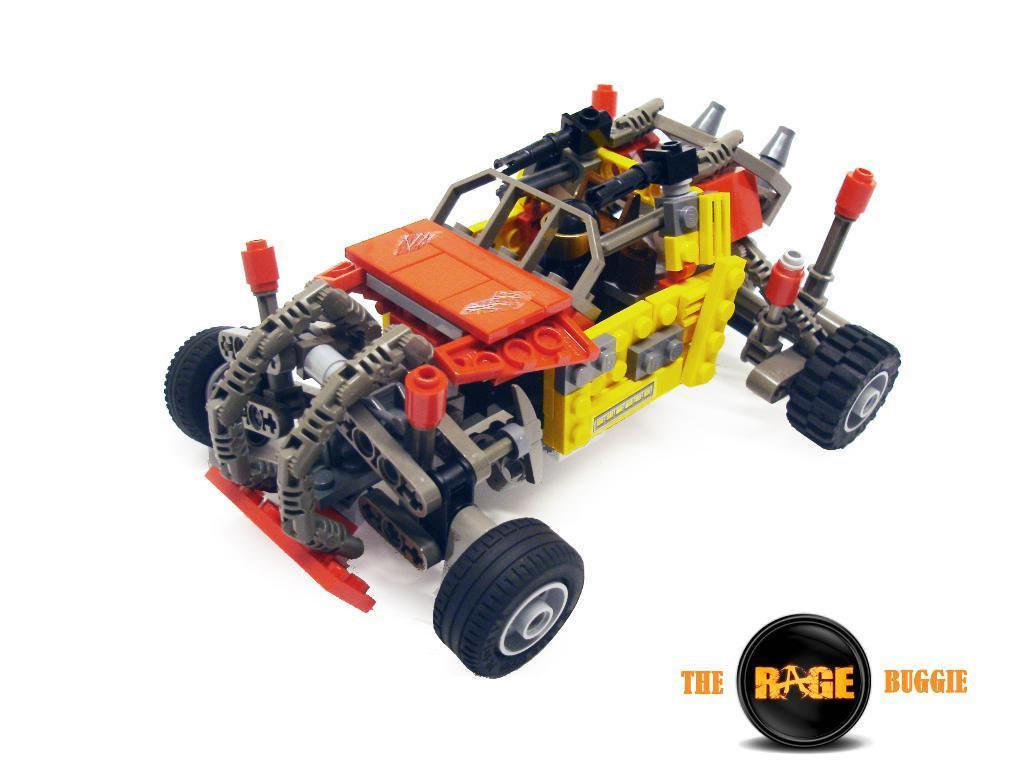Describe this image in one or two sentences. In the image there is a toy vehicle and on the right side bottom there is some is mentioned. 